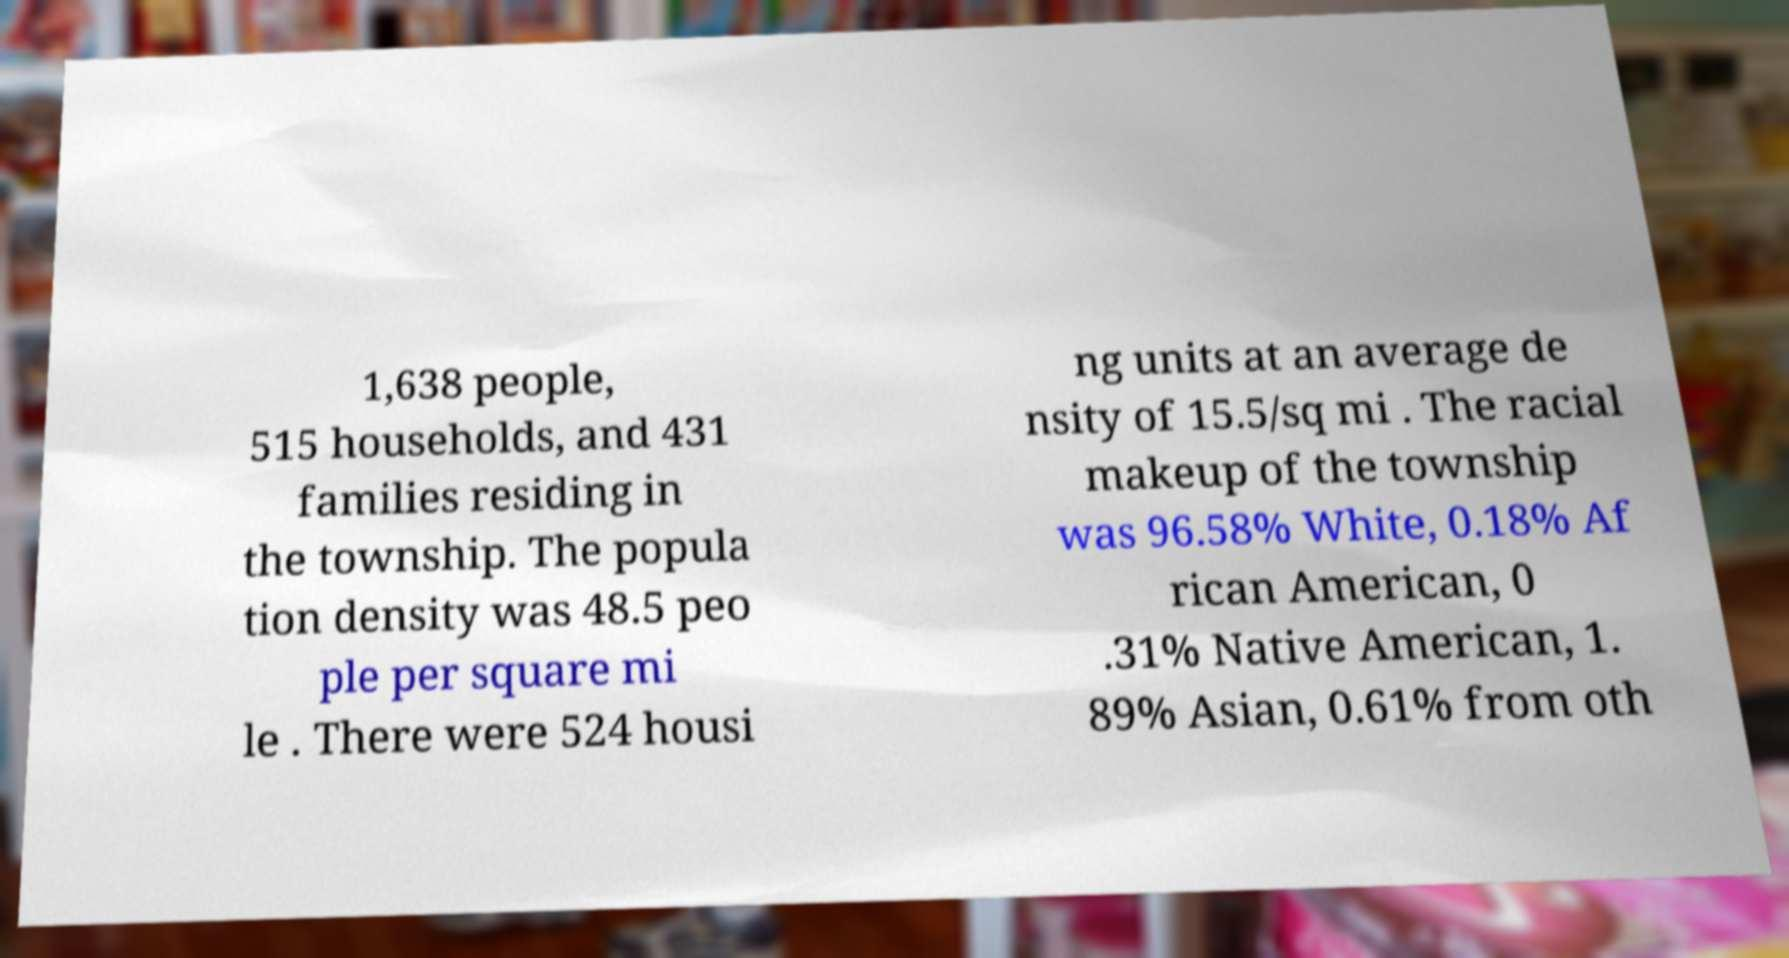Can you accurately transcribe the text from the provided image for me? 1,638 people, 515 households, and 431 families residing in the township. The popula tion density was 48.5 peo ple per square mi le . There were 524 housi ng units at an average de nsity of 15.5/sq mi . The racial makeup of the township was 96.58% White, 0.18% Af rican American, 0 .31% Native American, 1. 89% Asian, 0.61% from oth 